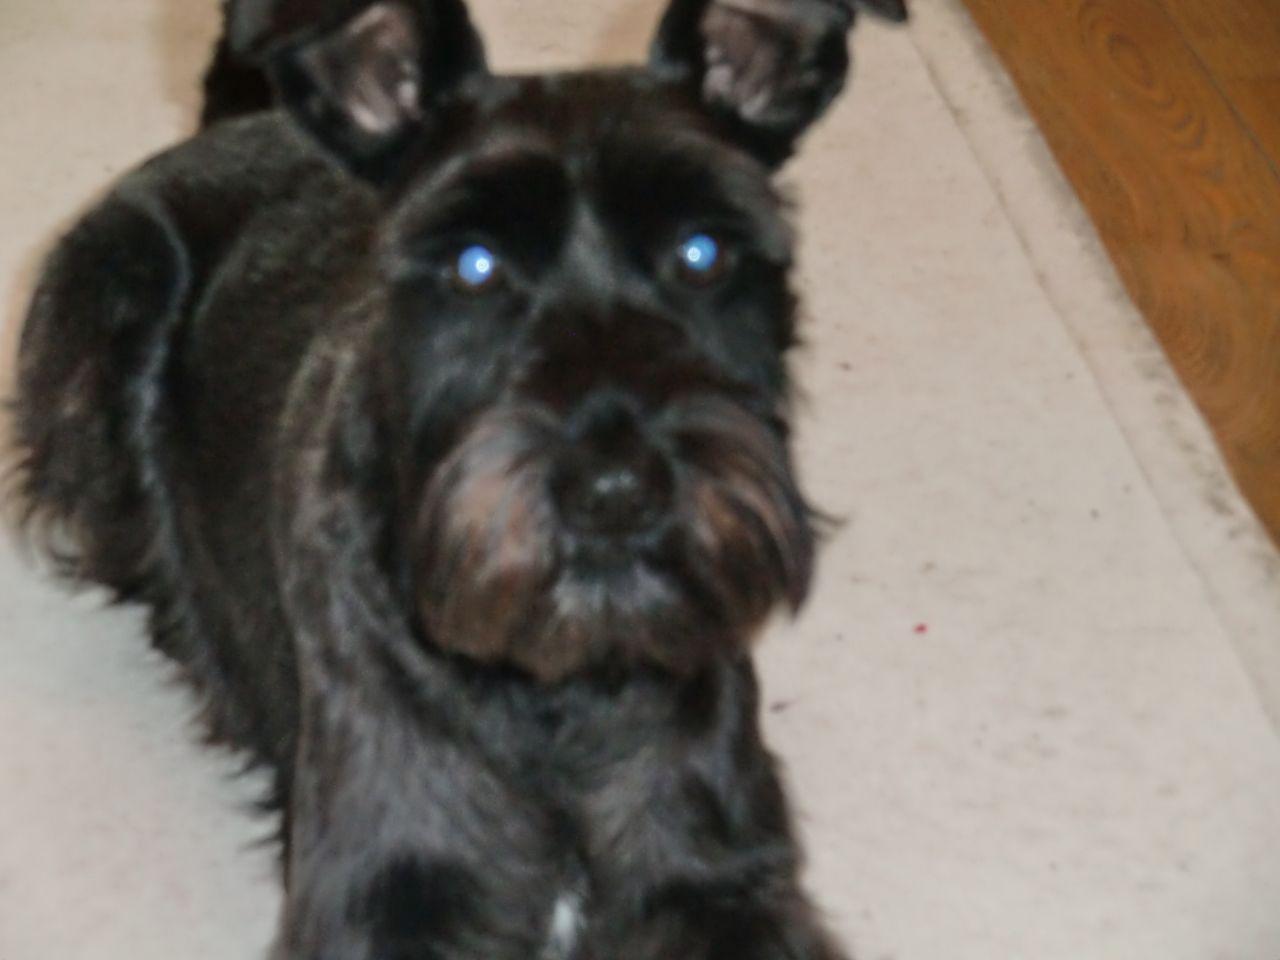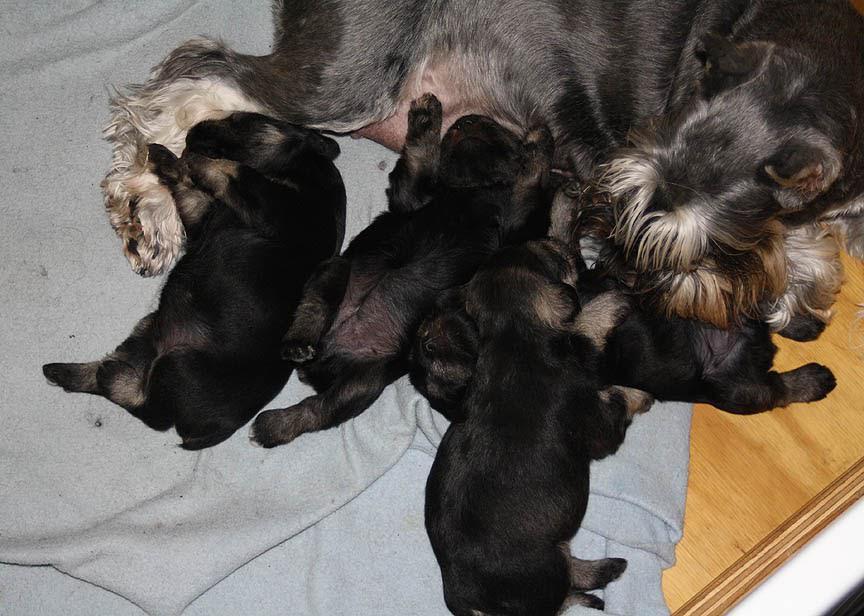The first image is the image on the left, the second image is the image on the right. Evaluate the accuracy of this statement regarding the images: "All dogs are schnauzer puppies, and at least some dogs have white eyebrows.". Is it true? Answer yes or no. No. The first image is the image on the left, the second image is the image on the right. Examine the images to the left and right. Is the description "There are at least three dogs in the right image." accurate? Answer yes or no. Yes. 